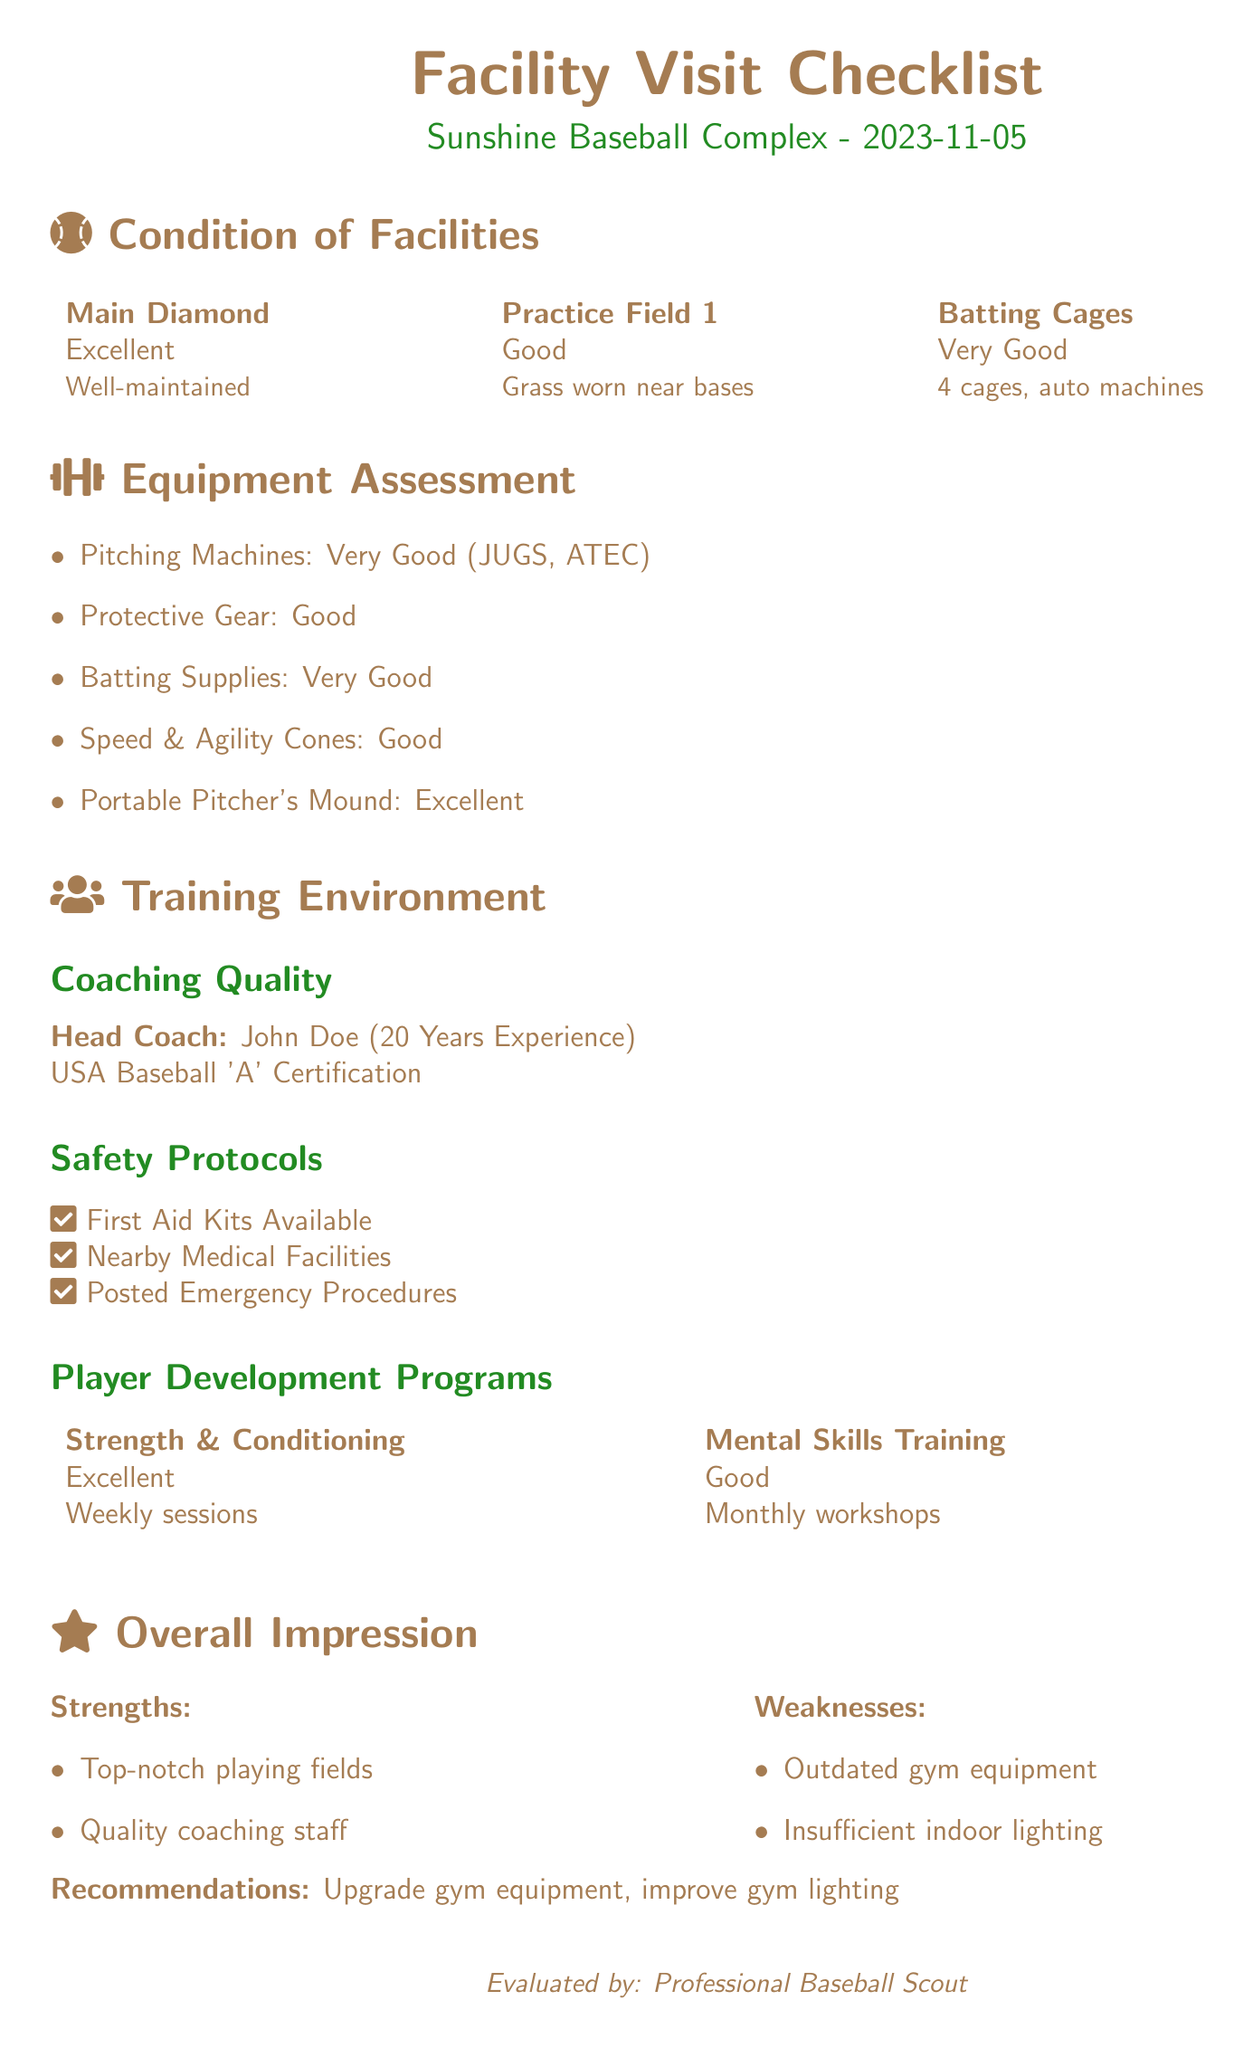What is the condition of the Main Diamond? The document states that the Main Diamond is in "Excellent" condition.
Answer: Excellent Who is the head coach? The head coach's name listed in the document is John Doe.
Answer: John Doe How many batting cages are available? The document indicates there are "4 cages" in the batting area.
Answer: 4 cages What is the quality rating of the portable pitcher's mound? According to the assessment, the portable pitcher's mound is rated as "Excellent."
Answer: Excellent What is one identified weakness of the facility? The document lists "Outdated gym equipment" as a weakness.
Answer: Outdated gym equipment How often do mental skills training workshops occur? The document mentions that mental skills training workshops happen on a "Monthly" basis.
Answer: Monthly What type of certification does the head coach hold? The document states that the head coach has a "USA Baseball 'A' Certification."
Answer: USA Baseball 'A' Certification What are the recommendations mentioned in the document? The recommendations include "Upgrade gym equipment, improve gym lighting."
Answer: Upgrade gym equipment, improve gym lighting What is the condition of the practice field? The practice field is noted to be in "Good" condition.
Answer: Good 